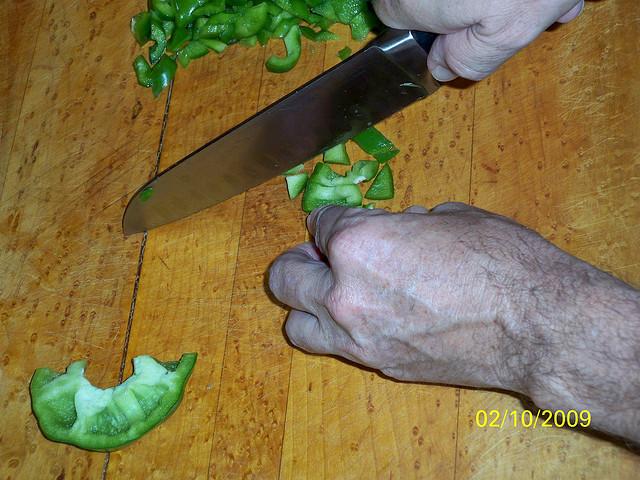Is that a chopping board?
Be succinct. Yes. Are these a woman's hands?
Give a very brief answer. No. What is being cut?
Give a very brief answer. Pepper. 